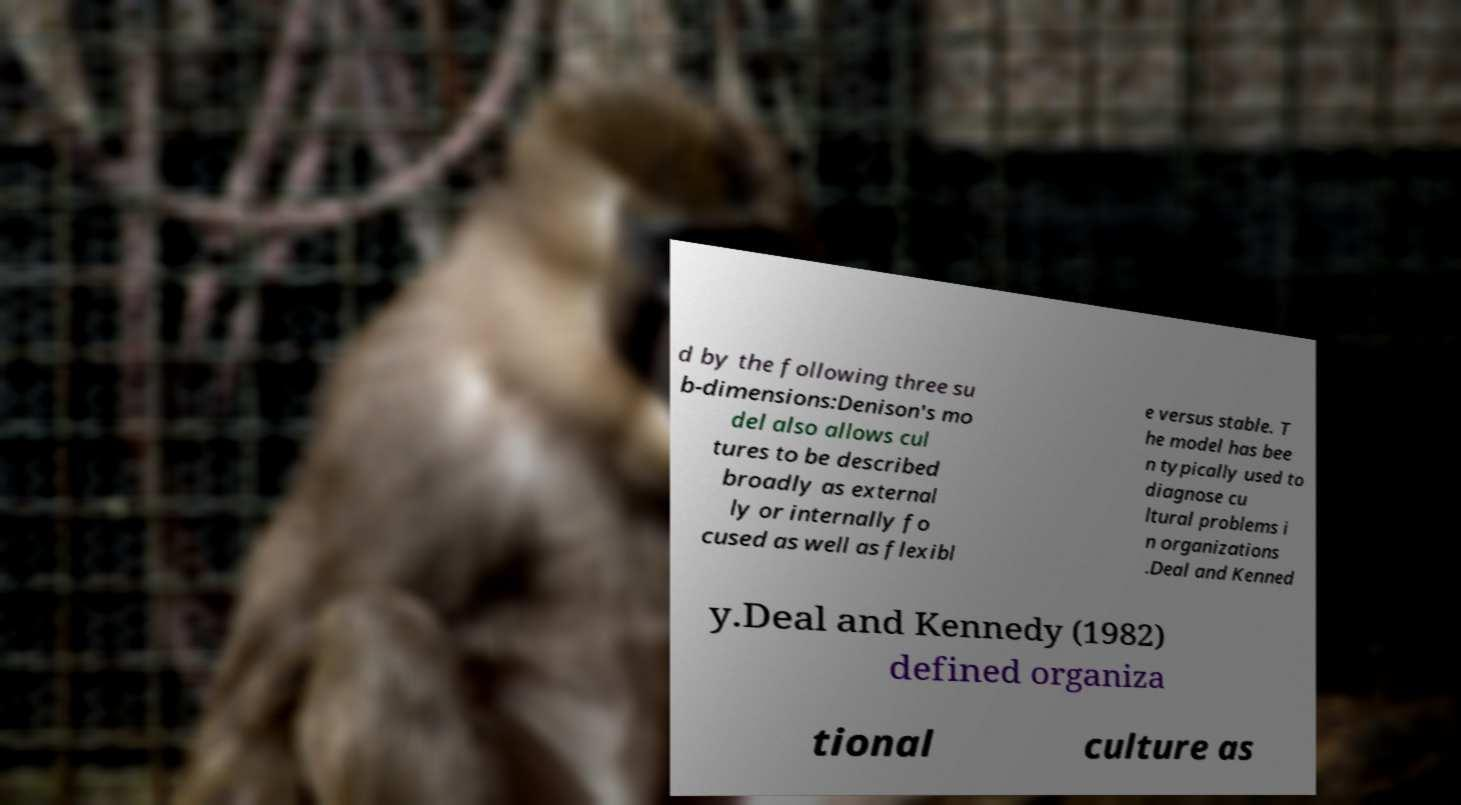Can you read and provide the text displayed in the image?This photo seems to have some interesting text. Can you extract and type it out for me? d by the following three su b-dimensions:Denison's mo del also allows cul tures to be described broadly as external ly or internally fo cused as well as flexibl e versus stable. T he model has bee n typically used to diagnose cu ltural problems i n organizations .Deal and Kenned y.Deal and Kennedy (1982) defined organiza tional culture as 